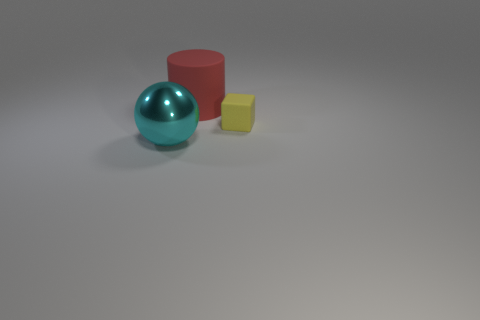Subtract all cylinders. How many objects are left? 2 Subtract 0 red blocks. How many objects are left? 3 Subtract all green cubes. Subtract all gray cylinders. How many cubes are left? 1 Subtract all large purple rubber objects. Subtract all large cylinders. How many objects are left? 2 Add 2 tiny objects. How many tiny objects are left? 3 Add 3 big blue cylinders. How many big blue cylinders exist? 3 Add 2 tiny yellow cubes. How many objects exist? 5 